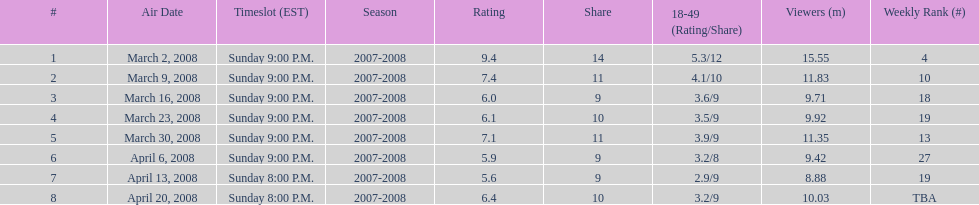What time slot did the show have for its first 6 episodes? Sunday 9:00 P.M. 